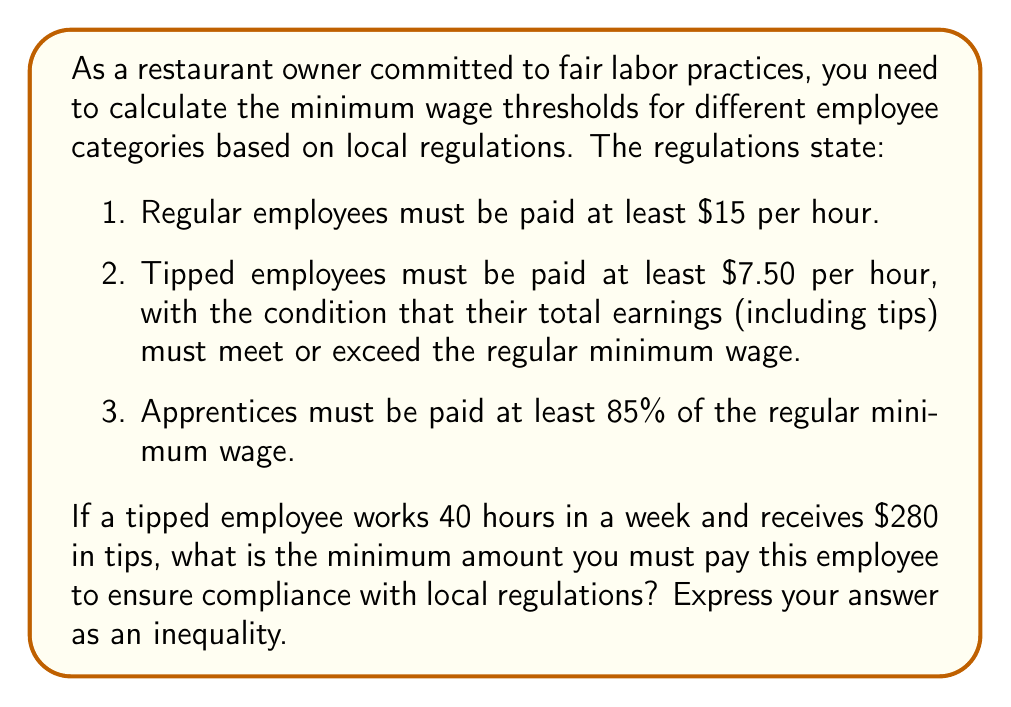What is the answer to this math problem? Let's approach this step-by-step:

1) First, we need to calculate the minimum weekly wage for a regular employee:
   $$40 \text{ hours} \times $15/\text{hour} = $600$$

2) For a tipped employee, we need to ensure their total earnings meet or exceed this amount.

3) Let $x$ be the hourly wage we pay the tipped employee. Then:
   $$40x + 280 \geq 600$$

4) This inequality represents that the employee's wage ($40x$) plus tips ($280) must be greater than or equal to the regular minimum wage ($600).

5) Solving the inequality:
   $$40x \geq 320$$
   $$x \geq 8$$

6) However, we also need to consider the minimum wage for tipped employees, which is $7.50 per hour.

7) Therefore, the final inequality is:
   $$x \geq \max(8, 7.50) = 8$$

Thus, you must pay the tipped employee at least $8 per hour to comply with regulations.
Answer: $x \geq 8$, where $x$ is the hourly wage paid to the tipped employee. 